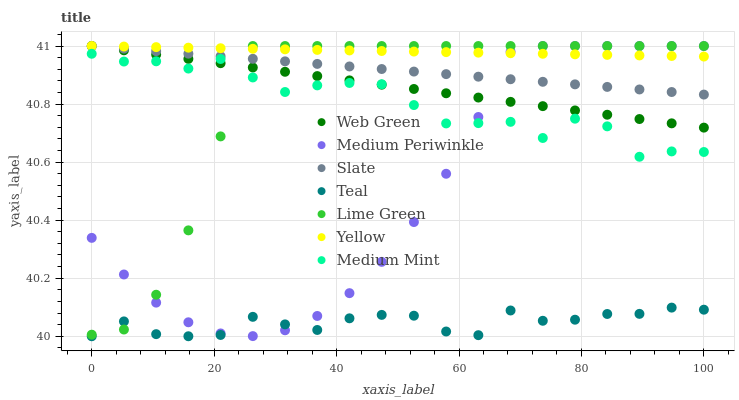Does Teal have the minimum area under the curve?
Answer yes or no. Yes. Does Yellow have the maximum area under the curve?
Answer yes or no. Yes. Does Slate have the minimum area under the curve?
Answer yes or no. No. Does Slate have the maximum area under the curve?
Answer yes or no. No. Is Web Green the smoothest?
Answer yes or no. Yes. Is Medium Mint the roughest?
Answer yes or no. Yes. Is Slate the smoothest?
Answer yes or no. No. Is Slate the roughest?
Answer yes or no. No. Does Teal have the lowest value?
Answer yes or no. Yes. Does Slate have the lowest value?
Answer yes or no. No. Does Lime Green have the highest value?
Answer yes or no. Yes. Does Teal have the highest value?
Answer yes or no. No. Is Medium Mint less than Yellow?
Answer yes or no. Yes. Is Web Green greater than Teal?
Answer yes or no. Yes. Does Slate intersect Medium Periwinkle?
Answer yes or no. Yes. Is Slate less than Medium Periwinkle?
Answer yes or no. No. Is Slate greater than Medium Periwinkle?
Answer yes or no. No. Does Medium Mint intersect Yellow?
Answer yes or no. No. 